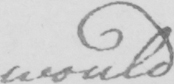What does this handwritten line say? would 